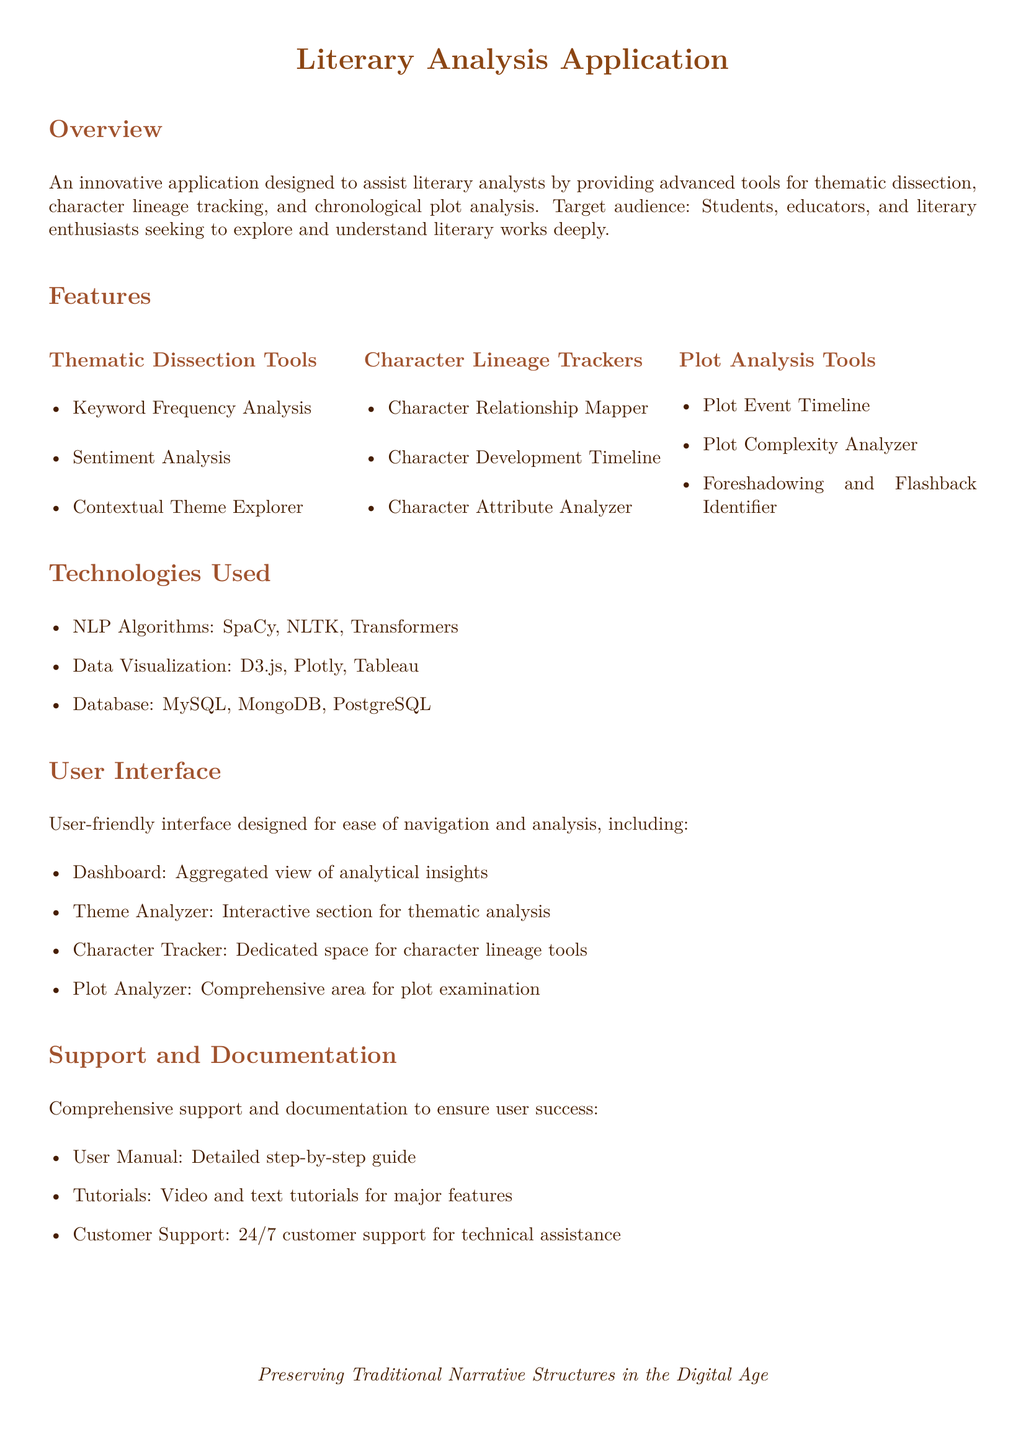What are the main tools for thematic dissection? The main tools for thematic dissection listed are Keyword Frequency Analysis, Sentiment Analysis, and Contextual Theme Explorer.
Answer: Keyword Frequency Analysis, Sentiment Analysis, Contextual Theme Explorer How many plot analysis tools are mentioned? The document lists three plot analysis tools: Plot Event Timeline, Plot Complexity Analyzer, and Foreshadowing and Flashback Identifier.
Answer: Three What does the user interface include for character tracking? The user interface features a dedicated space for character lineage tools labeled Character Tracker.
Answer: Character Tracker What is one technology used for data visualization? The document mentions D3.js, Plotly, and Tableau as technologies used for data visualization, with D3.js being one of them.
Answer: D3.js What type of support does the application offer? The application provides user manual, tutorials, and customer support for user success.
Answer: User manual, tutorials, customer support What is the target audience for the application? The target audience specified includes students, educators, and literary enthusiasts.
Answer: Students, educators, literary enthusiasts Which algorithm type is used in the application? The application utilizes NLP algorithms like SpaCy, NLTK, and Transformers for analysis.
Answer: NLP algorithms What is the color used for the title? The title color defined in the document is RGB (139, 69, 19).
Answer: RGB (139, 69, 19) 